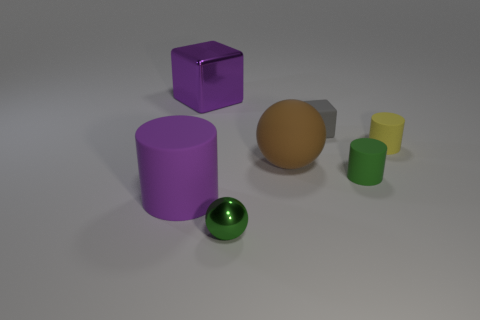What is the possible function of these objects? The objects appear to be simple geometric shapes that might serve educational or decorative purposes. They seem to represent a collection that could be used for teaching basic geometry or for a visual display in a setting like a classroom or an art installation. 